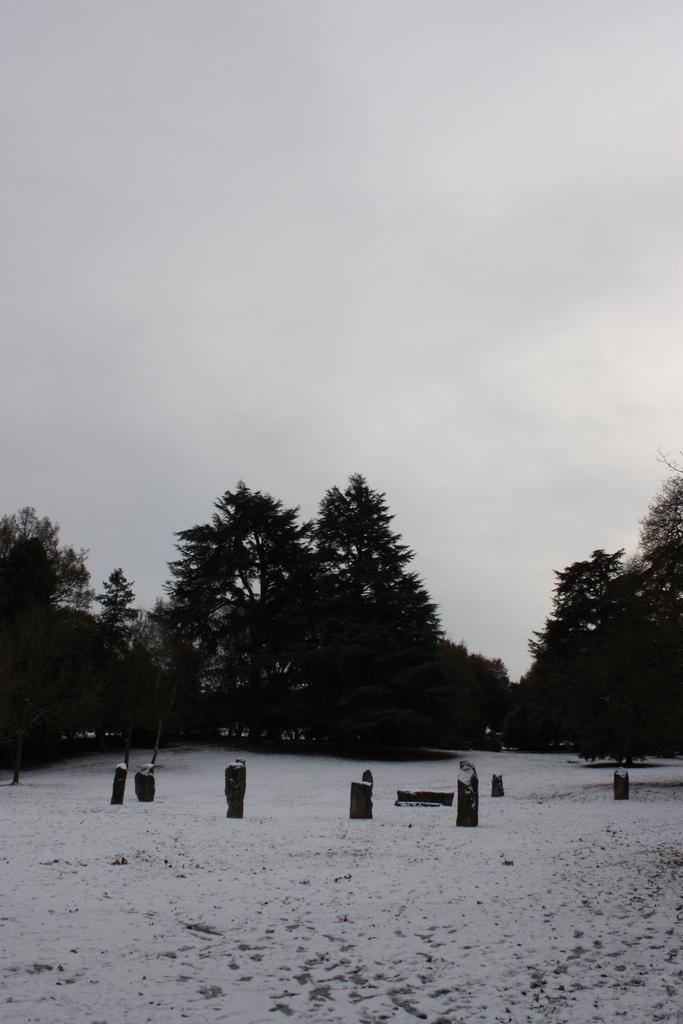Can you describe this image briefly? This picture might be taken from outside of the city. In this image, we can see some stones. In the background, there are some trees. On top there is a sky which is cloudy, at the bottom there is a land with some ice. 